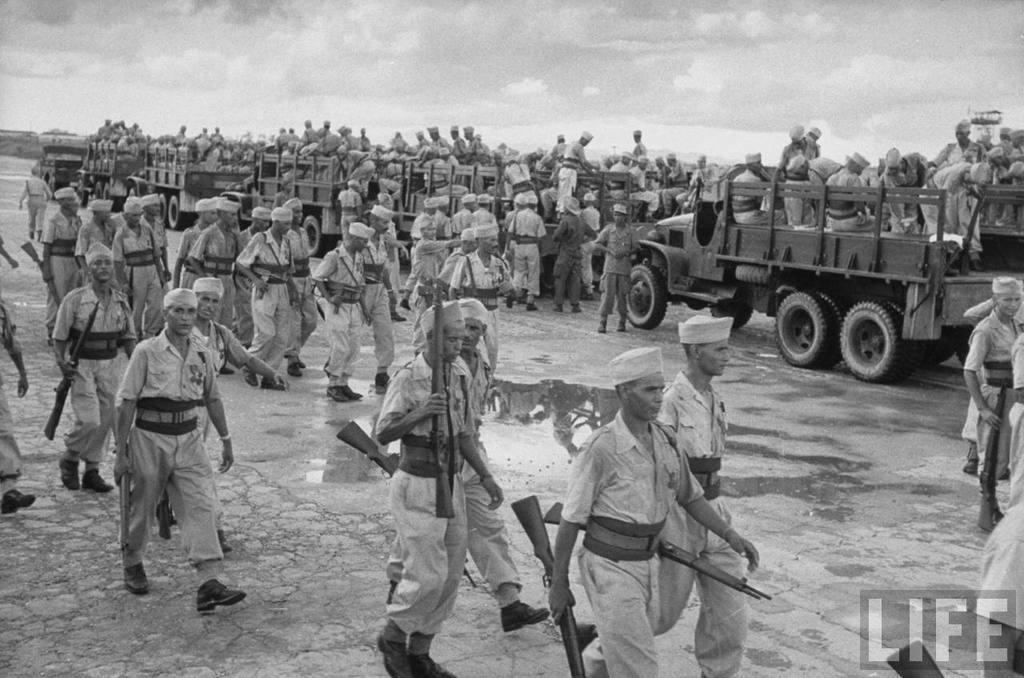How many people are in the image? There are many persons in the image. What vehicles can be seen in the front of the image? Trucks are visible in the front of the image. What are the persons holding in the image? The persons are holding guns. What is at the bottom of the image? There is ground at the bottom of the image. What can be seen in the sky at the top of the image? Clouds are present in the sky at the top of the image. What type of powder is being used by the persons in the image? There is no indication of any powder being used by the persons in the image. 